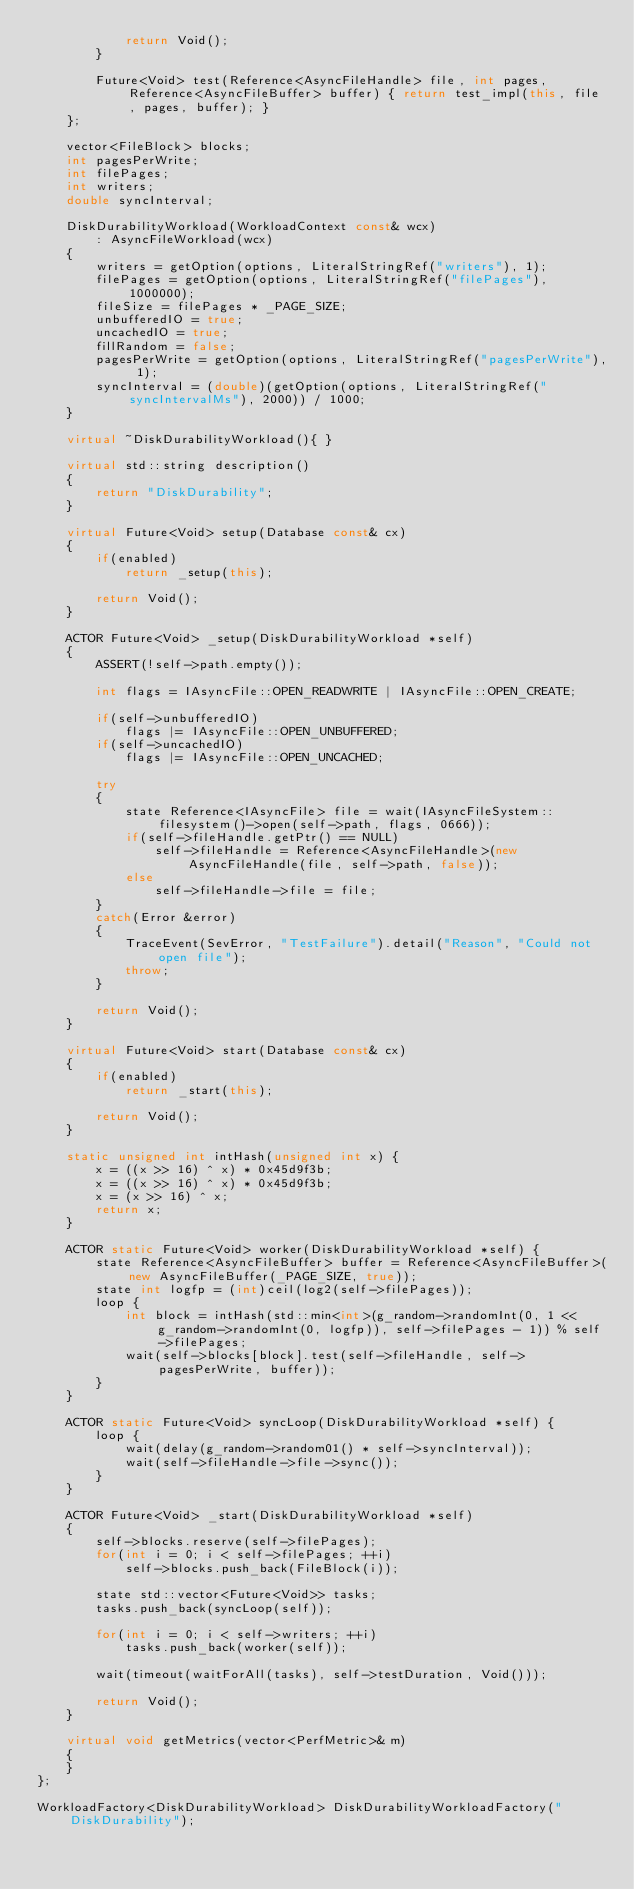Convert code to text. <code><loc_0><loc_0><loc_500><loc_500><_C++_>			return Void();
		}

		Future<Void> test(Reference<AsyncFileHandle> file, int pages, Reference<AsyncFileBuffer> buffer) { return test_impl(this, file, pages, buffer); }
	};

	vector<FileBlock> blocks;
	int pagesPerWrite;
	int filePages;
	int writers;
	double syncInterval;

	DiskDurabilityWorkload(WorkloadContext const& wcx)
		: AsyncFileWorkload(wcx)
	{
		writers = getOption(options, LiteralStringRef("writers"), 1);
		filePages = getOption(options, LiteralStringRef("filePages"), 1000000);
		fileSize = filePages * _PAGE_SIZE;
		unbufferedIO = true;
		uncachedIO = true;
		fillRandom = false;
		pagesPerWrite = getOption(options, LiteralStringRef("pagesPerWrite"), 1);
		syncInterval = (double)(getOption(options, LiteralStringRef("syncIntervalMs"), 2000)) / 1000;
	}

	virtual ~DiskDurabilityWorkload(){ }

	virtual std::string description()
	{
		return "DiskDurability";
	}

	virtual Future<Void> setup(Database const& cx)
	{
		if(enabled)
			return _setup(this);

		return Void();
	}

	ACTOR Future<Void> _setup(DiskDurabilityWorkload *self)
	{
		ASSERT(!self->path.empty());

		int flags = IAsyncFile::OPEN_READWRITE | IAsyncFile::OPEN_CREATE;

		if(self->unbufferedIO)
			flags |= IAsyncFile::OPEN_UNBUFFERED;
		if(self->uncachedIO)
			flags |= IAsyncFile::OPEN_UNCACHED;

		try
		{
			state Reference<IAsyncFile> file = wait(IAsyncFileSystem::filesystem()->open(self->path, flags, 0666));
			if(self->fileHandle.getPtr() == NULL)
				self->fileHandle = Reference<AsyncFileHandle>(new AsyncFileHandle(file, self->path, false));
			else
				self->fileHandle->file = file;
		}
		catch(Error &error)
		{
			TraceEvent(SevError, "TestFailure").detail("Reason", "Could not open file");
			throw;
		}

		return Void();
	}

	virtual Future<Void> start(Database const& cx)
	{
		if(enabled)
			return _start(this);

		return Void();
	}

	static unsigned int intHash(unsigned int x) {
		x = ((x >> 16) ^ x) * 0x45d9f3b;
		x = ((x >> 16) ^ x) * 0x45d9f3b;
		x = (x >> 16) ^ x;
		return x;
	}

	ACTOR static Future<Void> worker(DiskDurabilityWorkload *self) {
		state Reference<AsyncFileBuffer> buffer = Reference<AsyncFileBuffer>(new AsyncFileBuffer(_PAGE_SIZE, true));
		state int logfp = (int)ceil(log2(self->filePages));
		loop {
			int block = intHash(std::min<int>(g_random->randomInt(0, 1 << g_random->randomInt(0, logfp)), self->filePages - 1)) % self->filePages;
			wait(self->blocks[block].test(self->fileHandle, self->pagesPerWrite, buffer));
		}
	}

	ACTOR static Future<Void> syncLoop(DiskDurabilityWorkload *self) {
		loop {
			wait(delay(g_random->random01() * self->syncInterval));
			wait(self->fileHandle->file->sync());
		}
	}

	ACTOR Future<Void> _start(DiskDurabilityWorkload *self)
	{
		self->blocks.reserve(self->filePages);
		for(int i = 0; i < self->filePages; ++i)
			self->blocks.push_back(FileBlock(i));

		state std::vector<Future<Void>> tasks;
		tasks.push_back(syncLoop(self));

		for(int i = 0; i < self->writers; ++i)
			tasks.push_back(worker(self));

		wait(timeout(waitForAll(tasks), self->testDuration, Void()));

		return Void();
	}

	virtual void getMetrics(vector<PerfMetric>& m)
	{
	}
};

WorkloadFactory<DiskDurabilityWorkload> DiskDurabilityWorkloadFactory("DiskDurability");
</code> 